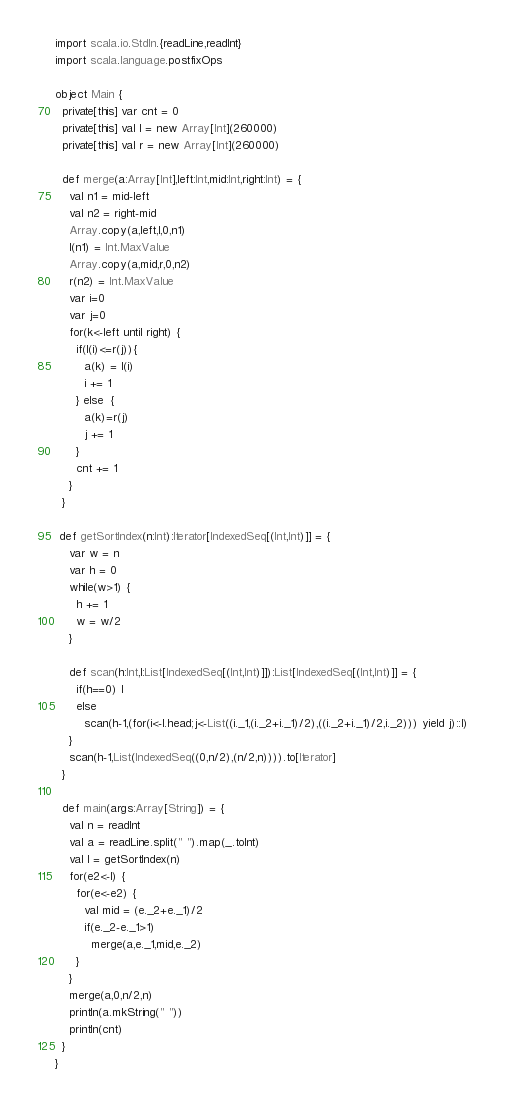<code> <loc_0><loc_0><loc_500><loc_500><_Scala_>import scala.io.StdIn.{readLine,readInt}
import scala.language.postfixOps

object Main {
  private[this] var cnt = 0
  private[this] val l = new Array[Int](260000)
  private[this] val r = new Array[Int](260000)

  def merge(a:Array[Int],left:Int,mid:Int,right:Int) = {
    val n1 = mid-left
    val n2 = right-mid
    Array.copy(a,left,l,0,n1)
    l(n1) = Int.MaxValue
    Array.copy(a,mid,r,0,n2)
    r(n2) = Int.MaxValue
    var i=0
    var j=0
    for(k<-left until right) {
      if(l(i)<=r(j)){
        a(k) = l(i)
        i += 1
      } else  {
        a(k)=r(j)
        j += 1
      }
      cnt += 1
    }
  }

 def getSortIndex(n:Int):Iterator[IndexedSeq[(Int,Int)]] = {
    var w = n
    var h = 0
    while(w>1) {
      h += 1
      w = w/2
    }

    def scan(h:Int,l:List[IndexedSeq[(Int,Int)]]):List[IndexedSeq[(Int,Int)]] = {
      if(h==0) l
      else
        scan(h-1,(for(i<-l.head;j<-List((i._1,(i._2+i._1)/2),((i._2+i._1)/2,i._2))) yield j)::l)
    }
    scan(h-1,List(IndexedSeq((0,n/2),(n/2,n)))).to[Iterator]
  }

  def main(args:Array[String]) = {
    val n = readInt
    val a = readLine.split(" ").map(_.toInt)
    val l = getSortIndex(n)
    for(e2<-l) {
      for(e<-e2) {
        val mid = (e._2+e._1)/2
        if(e._2-e._1>1)
          merge(a,e._1,mid,e._2)
      }
    }
    merge(a,0,n/2,n)
    println(a.mkString(" "))
    println(cnt)
  }
}</code> 